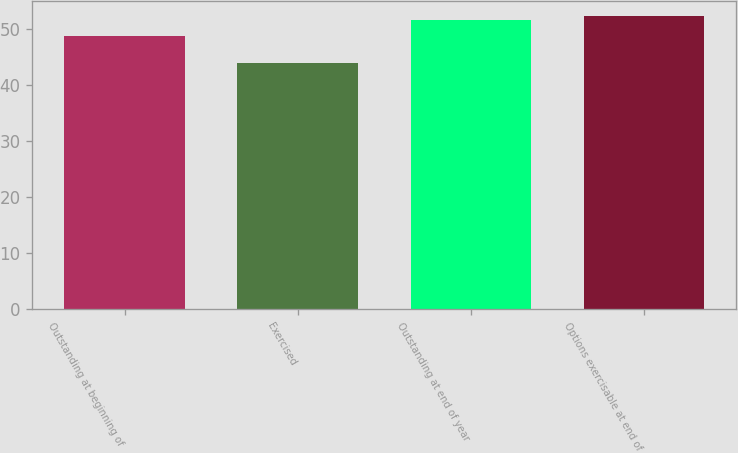Convert chart to OTSL. <chart><loc_0><loc_0><loc_500><loc_500><bar_chart><fcel>Outstanding at beginning of<fcel>Exercised<fcel>Outstanding at end of year<fcel>Options exercisable at end of<nl><fcel>48.61<fcel>43.86<fcel>51.53<fcel>52.3<nl></chart> 